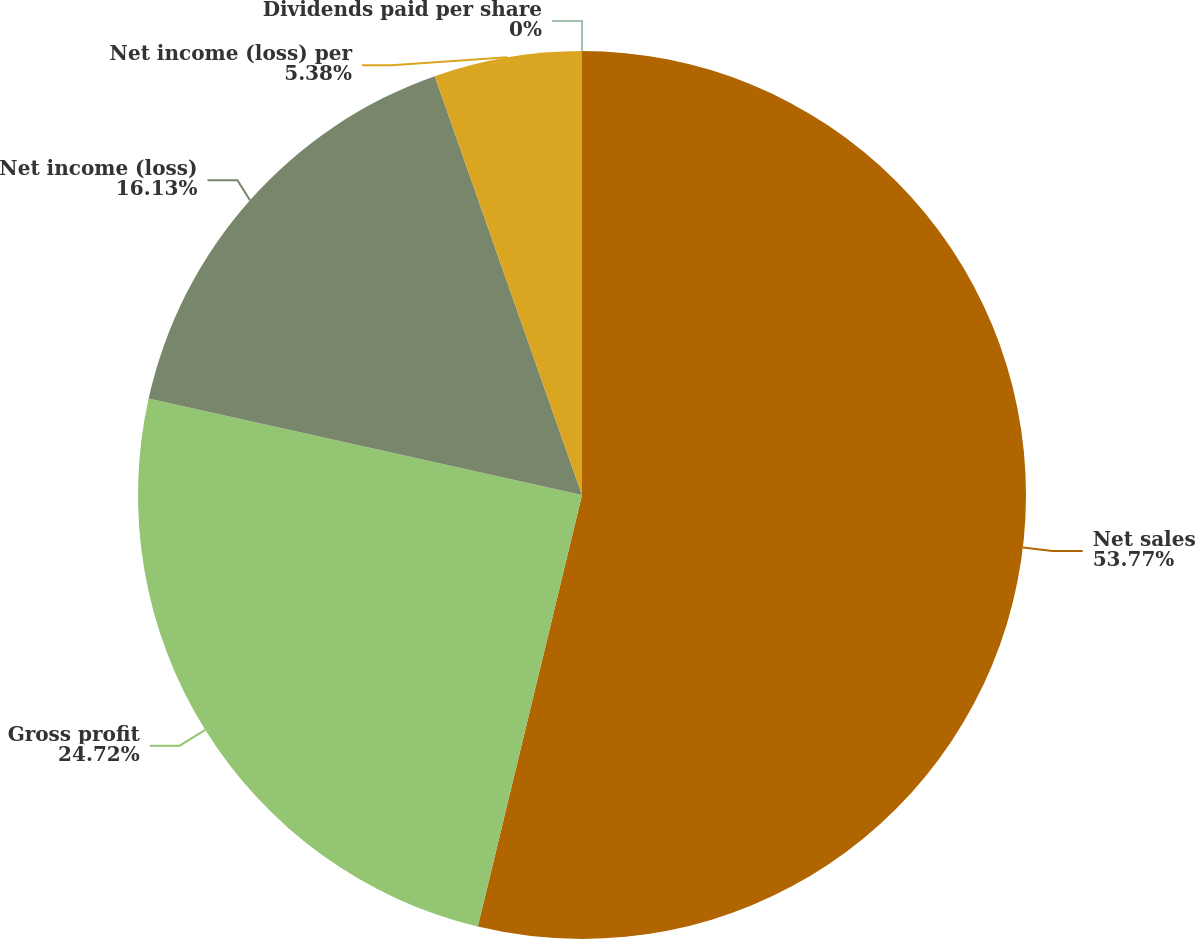Convert chart. <chart><loc_0><loc_0><loc_500><loc_500><pie_chart><fcel>Net sales<fcel>Gross profit<fcel>Net income (loss)<fcel>Net income (loss) per<fcel>Dividends paid per share<nl><fcel>53.77%<fcel>24.72%<fcel>16.13%<fcel>5.38%<fcel>0.0%<nl></chart> 